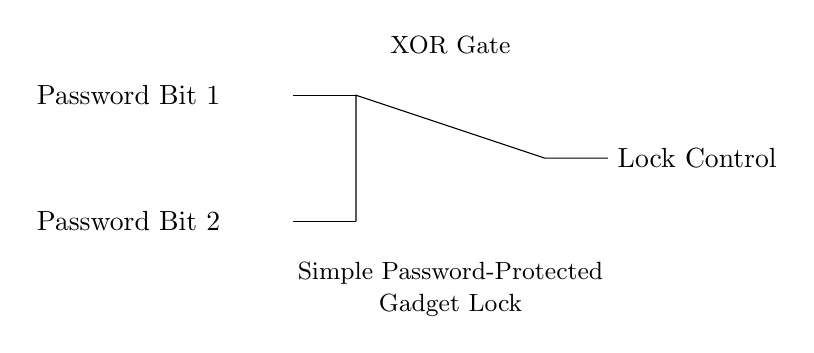What are the two inputs to the XOR gate? The inputs to the XOR gate are "Password Bit 1" and "Password Bit 2," which are shown connected to the gate in the circuit.
Answer: Password Bit 1, Password Bit 2 What is the output of the XOR gate called? The output of the XOR gate is labeled as "Lock Control," indicating its function in controlling the lock based on the input password bits.
Answer: Lock Control What type of circuit is depicted in the diagram? The circuit shown is a simple password-protected gadget lock, as indicated by the labels within the circuit diagram itself.
Answer: Simple Password-Protected Gadget Lock How many input lines are connected to the XOR gate? There are two input lines connected to the XOR gate, as each password bit feeds directly into the gate's distinct input terminals.
Answer: Two What is the function of the XOR gate in this circuit? The XOR gate functions to output a true signal (or lock control) only when exactly one of the two inputs (password bits) is true, which is crucial for a password protection mechanism.
Answer: Conditional Lock Control If both password bits are the same, what will be the output of the XOR gate? When both password bits are the same (either both true or both false), the output of the XOR gate will be false, thus the lock will not engage.
Answer: False What happens when one password bit is true and the other is false? If one password bit is true and the other is false, the output of the XOR gate will be true, indicating that the correct password combination is detected, and the lock will engage.
Answer: True 